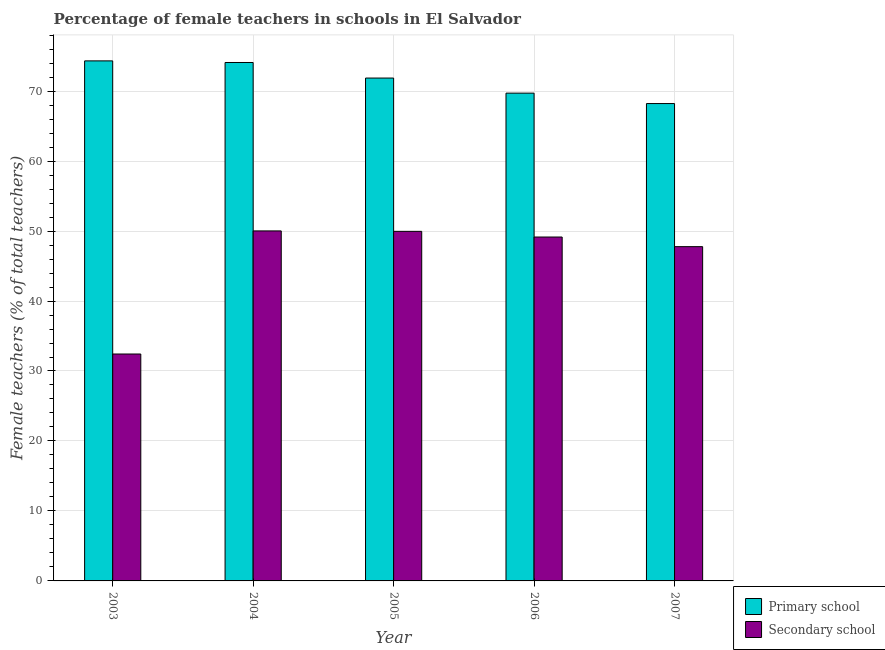How many groups of bars are there?
Offer a terse response. 5. Are the number of bars per tick equal to the number of legend labels?
Provide a succinct answer. Yes. How many bars are there on the 2nd tick from the left?
Your answer should be very brief. 2. What is the label of the 3rd group of bars from the left?
Offer a very short reply. 2005. What is the percentage of female teachers in secondary schools in 2005?
Keep it short and to the point. 49.96. Across all years, what is the maximum percentage of female teachers in secondary schools?
Provide a short and direct response. 50.02. Across all years, what is the minimum percentage of female teachers in primary schools?
Give a very brief answer. 68.22. In which year was the percentage of female teachers in secondary schools maximum?
Keep it short and to the point. 2004. In which year was the percentage of female teachers in primary schools minimum?
Make the answer very short. 2007. What is the total percentage of female teachers in secondary schools in the graph?
Offer a terse response. 229.32. What is the difference between the percentage of female teachers in primary schools in 2006 and that in 2007?
Your answer should be very brief. 1.49. What is the difference between the percentage of female teachers in primary schools in 2003 and the percentage of female teachers in secondary schools in 2005?
Provide a succinct answer. 2.45. What is the average percentage of female teachers in secondary schools per year?
Provide a short and direct response. 45.86. In the year 2007, what is the difference between the percentage of female teachers in secondary schools and percentage of female teachers in primary schools?
Keep it short and to the point. 0. In how many years, is the percentage of female teachers in secondary schools greater than 62 %?
Ensure brevity in your answer.  0. What is the ratio of the percentage of female teachers in primary schools in 2005 to that in 2007?
Keep it short and to the point. 1.05. Is the difference between the percentage of female teachers in secondary schools in 2006 and 2007 greater than the difference between the percentage of female teachers in primary schools in 2006 and 2007?
Make the answer very short. No. What is the difference between the highest and the second highest percentage of female teachers in secondary schools?
Provide a succinct answer. 0.06. What is the difference between the highest and the lowest percentage of female teachers in secondary schools?
Offer a terse response. 17.59. In how many years, is the percentage of female teachers in primary schools greater than the average percentage of female teachers in primary schools taken over all years?
Give a very brief answer. 3. What does the 1st bar from the left in 2007 represents?
Your response must be concise. Primary school. What does the 2nd bar from the right in 2003 represents?
Give a very brief answer. Primary school. How many bars are there?
Keep it short and to the point. 10. Are the values on the major ticks of Y-axis written in scientific E-notation?
Give a very brief answer. No. Does the graph contain any zero values?
Keep it short and to the point. No. Does the graph contain grids?
Make the answer very short. Yes. Where does the legend appear in the graph?
Your answer should be very brief. Bottom right. How many legend labels are there?
Provide a short and direct response. 2. How are the legend labels stacked?
Give a very brief answer. Vertical. What is the title of the graph?
Your response must be concise. Percentage of female teachers in schools in El Salvador. Does "DAC donors" appear as one of the legend labels in the graph?
Make the answer very short. No. What is the label or title of the X-axis?
Your answer should be very brief. Year. What is the label or title of the Y-axis?
Make the answer very short. Female teachers (% of total teachers). What is the Female teachers (% of total teachers) of Primary school in 2003?
Offer a very short reply. 74.32. What is the Female teachers (% of total teachers) in Secondary school in 2003?
Provide a short and direct response. 32.43. What is the Female teachers (% of total teachers) of Primary school in 2004?
Your answer should be very brief. 74.09. What is the Female teachers (% of total teachers) of Secondary school in 2004?
Provide a succinct answer. 50.02. What is the Female teachers (% of total teachers) in Primary school in 2005?
Provide a short and direct response. 71.86. What is the Female teachers (% of total teachers) of Secondary school in 2005?
Your answer should be compact. 49.96. What is the Female teachers (% of total teachers) in Primary school in 2006?
Offer a terse response. 69.71. What is the Female teachers (% of total teachers) in Secondary school in 2006?
Keep it short and to the point. 49.14. What is the Female teachers (% of total teachers) in Primary school in 2007?
Provide a short and direct response. 68.22. What is the Female teachers (% of total teachers) of Secondary school in 2007?
Your response must be concise. 47.77. Across all years, what is the maximum Female teachers (% of total teachers) of Primary school?
Your answer should be compact. 74.32. Across all years, what is the maximum Female teachers (% of total teachers) in Secondary school?
Your answer should be compact. 50.02. Across all years, what is the minimum Female teachers (% of total teachers) of Primary school?
Your response must be concise. 68.22. Across all years, what is the minimum Female teachers (% of total teachers) in Secondary school?
Your answer should be compact. 32.43. What is the total Female teachers (% of total teachers) in Primary school in the graph?
Your answer should be compact. 358.2. What is the total Female teachers (% of total teachers) of Secondary school in the graph?
Your answer should be very brief. 229.32. What is the difference between the Female teachers (% of total teachers) in Primary school in 2003 and that in 2004?
Keep it short and to the point. 0.23. What is the difference between the Female teachers (% of total teachers) in Secondary school in 2003 and that in 2004?
Your answer should be very brief. -17.59. What is the difference between the Female teachers (% of total teachers) of Primary school in 2003 and that in 2005?
Your answer should be very brief. 2.45. What is the difference between the Female teachers (% of total teachers) in Secondary school in 2003 and that in 2005?
Offer a terse response. -17.53. What is the difference between the Female teachers (% of total teachers) in Primary school in 2003 and that in 2006?
Your answer should be compact. 4.61. What is the difference between the Female teachers (% of total teachers) in Secondary school in 2003 and that in 2006?
Give a very brief answer. -16.72. What is the difference between the Female teachers (% of total teachers) of Primary school in 2003 and that in 2007?
Make the answer very short. 6.1. What is the difference between the Female teachers (% of total teachers) of Secondary school in 2003 and that in 2007?
Provide a short and direct response. -15.34. What is the difference between the Female teachers (% of total teachers) of Primary school in 2004 and that in 2005?
Give a very brief answer. 2.22. What is the difference between the Female teachers (% of total teachers) in Secondary school in 2004 and that in 2005?
Provide a succinct answer. 0.06. What is the difference between the Female teachers (% of total teachers) in Primary school in 2004 and that in 2006?
Provide a succinct answer. 4.38. What is the difference between the Female teachers (% of total teachers) in Secondary school in 2004 and that in 2006?
Keep it short and to the point. 0.87. What is the difference between the Female teachers (% of total teachers) of Primary school in 2004 and that in 2007?
Your response must be concise. 5.87. What is the difference between the Female teachers (% of total teachers) of Secondary school in 2004 and that in 2007?
Your response must be concise. 2.25. What is the difference between the Female teachers (% of total teachers) in Primary school in 2005 and that in 2006?
Give a very brief answer. 2.15. What is the difference between the Female teachers (% of total teachers) of Secondary school in 2005 and that in 2006?
Your answer should be very brief. 0.81. What is the difference between the Female teachers (% of total teachers) of Primary school in 2005 and that in 2007?
Provide a succinct answer. 3.65. What is the difference between the Female teachers (% of total teachers) of Secondary school in 2005 and that in 2007?
Ensure brevity in your answer.  2.19. What is the difference between the Female teachers (% of total teachers) in Primary school in 2006 and that in 2007?
Provide a short and direct response. 1.49. What is the difference between the Female teachers (% of total teachers) in Secondary school in 2006 and that in 2007?
Offer a terse response. 1.38. What is the difference between the Female teachers (% of total teachers) of Primary school in 2003 and the Female teachers (% of total teachers) of Secondary school in 2004?
Give a very brief answer. 24.3. What is the difference between the Female teachers (% of total teachers) of Primary school in 2003 and the Female teachers (% of total teachers) of Secondary school in 2005?
Give a very brief answer. 24.36. What is the difference between the Female teachers (% of total teachers) of Primary school in 2003 and the Female teachers (% of total teachers) of Secondary school in 2006?
Your answer should be compact. 25.17. What is the difference between the Female teachers (% of total teachers) in Primary school in 2003 and the Female teachers (% of total teachers) in Secondary school in 2007?
Provide a succinct answer. 26.55. What is the difference between the Female teachers (% of total teachers) in Primary school in 2004 and the Female teachers (% of total teachers) in Secondary school in 2005?
Make the answer very short. 24.13. What is the difference between the Female teachers (% of total teachers) of Primary school in 2004 and the Female teachers (% of total teachers) of Secondary school in 2006?
Provide a succinct answer. 24.94. What is the difference between the Female teachers (% of total teachers) of Primary school in 2004 and the Female teachers (% of total teachers) of Secondary school in 2007?
Provide a short and direct response. 26.32. What is the difference between the Female teachers (% of total teachers) of Primary school in 2005 and the Female teachers (% of total teachers) of Secondary school in 2006?
Ensure brevity in your answer.  22.72. What is the difference between the Female teachers (% of total teachers) in Primary school in 2005 and the Female teachers (% of total teachers) in Secondary school in 2007?
Offer a very short reply. 24.09. What is the difference between the Female teachers (% of total teachers) of Primary school in 2006 and the Female teachers (% of total teachers) of Secondary school in 2007?
Offer a very short reply. 21.94. What is the average Female teachers (% of total teachers) in Primary school per year?
Your response must be concise. 71.64. What is the average Female teachers (% of total teachers) of Secondary school per year?
Your response must be concise. 45.86. In the year 2003, what is the difference between the Female teachers (% of total teachers) in Primary school and Female teachers (% of total teachers) in Secondary school?
Provide a short and direct response. 41.89. In the year 2004, what is the difference between the Female teachers (% of total teachers) in Primary school and Female teachers (% of total teachers) in Secondary school?
Give a very brief answer. 24.07. In the year 2005, what is the difference between the Female teachers (% of total teachers) in Primary school and Female teachers (% of total teachers) in Secondary school?
Ensure brevity in your answer.  21.91. In the year 2006, what is the difference between the Female teachers (% of total teachers) of Primary school and Female teachers (% of total teachers) of Secondary school?
Provide a succinct answer. 20.56. In the year 2007, what is the difference between the Female teachers (% of total teachers) in Primary school and Female teachers (% of total teachers) in Secondary school?
Offer a very short reply. 20.45. What is the ratio of the Female teachers (% of total teachers) in Primary school in 2003 to that in 2004?
Ensure brevity in your answer.  1. What is the ratio of the Female teachers (% of total teachers) of Secondary school in 2003 to that in 2004?
Offer a terse response. 0.65. What is the ratio of the Female teachers (% of total teachers) in Primary school in 2003 to that in 2005?
Make the answer very short. 1.03. What is the ratio of the Female teachers (% of total teachers) in Secondary school in 2003 to that in 2005?
Make the answer very short. 0.65. What is the ratio of the Female teachers (% of total teachers) in Primary school in 2003 to that in 2006?
Your response must be concise. 1.07. What is the ratio of the Female teachers (% of total teachers) of Secondary school in 2003 to that in 2006?
Offer a terse response. 0.66. What is the ratio of the Female teachers (% of total teachers) in Primary school in 2003 to that in 2007?
Your answer should be very brief. 1.09. What is the ratio of the Female teachers (% of total teachers) in Secondary school in 2003 to that in 2007?
Your answer should be compact. 0.68. What is the ratio of the Female teachers (% of total teachers) in Primary school in 2004 to that in 2005?
Your answer should be compact. 1.03. What is the ratio of the Female teachers (% of total teachers) of Primary school in 2004 to that in 2006?
Your response must be concise. 1.06. What is the ratio of the Female teachers (% of total teachers) in Secondary school in 2004 to that in 2006?
Provide a succinct answer. 1.02. What is the ratio of the Female teachers (% of total teachers) in Primary school in 2004 to that in 2007?
Offer a very short reply. 1.09. What is the ratio of the Female teachers (% of total teachers) of Secondary school in 2004 to that in 2007?
Offer a very short reply. 1.05. What is the ratio of the Female teachers (% of total teachers) in Primary school in 2005 to that in 2006?
Make the answer very short. 1.03. What is the ratio of the Female teachers (% of total teachers) of Secondary school in 2005 to that in 2006?
Keep it short and to the point. 1.02. What is the ratio of the Female teachers (% of total teachers) in Primary school in 2005 to that in 2007?
Keep it short and to the point. 1.05. What is the ratio of the Female teachers (% of total teachers) in Secondary school in 2005 to that in 2007?
Provide a short and direct response. 1.05. What is the ratio of the Female teachers (% of total teachers) of Primary school in 2006 to that in 2007?
Offer a terse response. 1.02. What is the ratio of the Female teachers (% of total teachers) of Secondary school in 2006 to that in 2007?
Keep it short and to the point. 1.03. What is the difference between the highest and the second highest Female teachers (% of total teachers) of Primary school?
Offer a very short reply. 0.23. What is the difference between the highest and the second highest Female teachers (% of total teachers) in Secondary school?
Provide a short and direct response. 0.06. What is the difference between the highest and the lowest Female teachers (% of total teachers) of Primary school?
Make the answer very short. 6.1. What is the difference between the highest and the lowest Female teachers (% of total teachers) of Secondary school?
Your answer should be very brief. 17.59. 